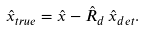<formula> <loc_0><loc_0><loc_500><loc_500>\hat { x } _ { t r u e } = \hat { x } - \hat { R } _ { d } \, \hat { x } _ { d e t } .</formula> 